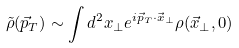<formula> <loc_0><loc_0><loc_500><loc_500>\tilde { \rho } ( \vec { p } _ { T } ) \sim \int d ^ { 2 } x _ { \perp } e ^ { i \vec { p } _ { T } \cdot \vec { x } _ { \perp } } \rho ( \vec { x } _ { \perp } , 0 )</formula> 